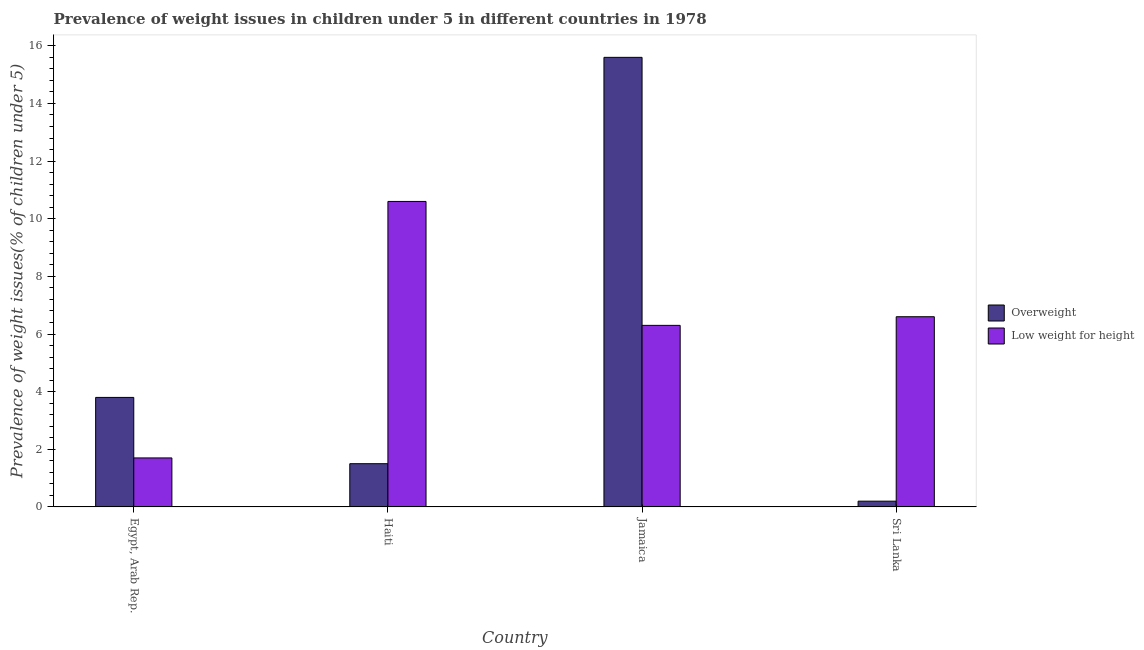How many groups of bars are there?
Provide a short and direct response. 4. Are the number of bars per tick equal to the number of legend labels?
Offer a terse response. Yes. Are the number of bars on each tick of the X-axis equal?
Offer a terse response. Yes. How many bars are there on the 4th tick from the left?
Your answer should be very brief. 2. What is the label of the 3rd group of bars from the left?
Your answer should be very brief. Jamaica. What is the percentage of underweight children in Egypt, Arab Rep.?
Provide a short and direct response. 1.7. Across all countries, what is the maximum percentage of underweight children?
Your response must be concise. 10.6. Across all countries, what is the minimum percentage of overweight children?
Your answer should be compact. 0.2. In which country was the percentage of overweight children maximum?
Provide a short and direct response. Jamaica. In which country was the percentage of overweight children minimum?
Offer a terse response. Sri Lanka. What is the total percentage of underweight children in the graph?
Your answer should be very brief. 25.2. What is the difference between the percentage of underweight children in Egypt, Arab Rep. and that in Jamaica?
Offer a terse response. -4.6. What is the difference between the percentage of overweight children in Sri Lanka and the percentage of underweight children in Egypt, Arab Rep.?
Your answer should be compact. -1.5. What is the average percentage of underweight children per country?
Keep it short and to the point. 6.3. What is the difference between the percentage of underweight children and percentage of overweight children in Jamaica?
Your answer should be compact. -9.3. In how many countries, is the percentage of underweight children greater than 15.6 %?
Provide a succinct answer. 0. What is the ratio of the percentage of underweight children in Jamaica to that in Sri Lanka?
Provide a short and direct response. 0.95. Is the percentage of overweight children in Haiti less than that in Sri Lanka?
Ensure brevity in your answer.  No. What is the difference between the highest and the second highest percentage of underweight children?
Give a very brief answer. 4. What is the difference between the highest and the lowest percentage of overweight children?
Keep it short and to the point. 15.4. What does the 2nd bar from the left in Jamaica represents?
Keep it short and to the point. Low weight for height. What does the 2nd bar from the right in Jamaica represents?
Make the answer very short. Overweight. How many bars are there?
Make the answer very short. 8. Are all the bars in the graph horizontal?
Make the answer very short. No. How many countries are there in the graph?
Provide a short and direct response. 4. What is the difference between two consecutive major ticks on the Y-axis?
Keep it short and to the point. 2. Does the graph contain grids?
Offer a very short reply. No. Where does the legend appear in the graph?
Offer a very short reply. Center right. How many legend labels are there?
Ensure brevity in your answer.  2. How are the legend labels stacked?
Ensure brevity in your answer.  Vertical. What is the title of the graph?
Your answer should be very brief. Prevalence of weight issues in children under 5 in different countries in 1978. Does "Register a property" appear as one of the legend labels in the graph?
Your answer should be compact. No. What is the label or title of the X-axis?
Your response must be concise. Country. What is the label or title of the Y-axis?
Your answer should be compact. Prevalence of weight issues(% of children under 5). What is the Prevalence of weight issues(% of children under 5) in Overweight in Egypt, Arab Rep.?
Provide a short and direct response. 3.8. What is the Prevalence of weight issues(% of children under 5) of Low weight for height in Egypt, Arab Rep.?
Provide a succinct answer. 1.7. What is the Prevalence of weight issues(% of children under 5) in Low weight for height in Haiti?
Your answer should be very brief. 10.6. What is the Prevalence of weight issues(% of children under 5) of Overweight in Jamaica?
Your answer should be compact. 15.6. What is the Prevalence of weight issues(% of children under 5) in Low weight for height in Jamaica?
Provide a short and direct response. 6.3. What is the Prevalence of weight issues(% of children under 5) of Overweight in Sri Lanka?
Your response must be concise. 0.2. What is the Prevalence of weight issues(% of children under 5) of Low weight for height in Sri Lanka?
Ensure brevity in your answer.  6.6. Across all countries, what is the maximum Prevalence of weight issues(% of children under 5) of Overweight?
Provide a succinct answer. 15.6. Across all countries, what is the maximum Prevalence of weight issues(% of children under 5) of Low weight for height?
Ensure brevity in your answer.  10.6. Across all countries, what is the minimum Prevalence of weight issues(% of children under 5) in Overweight?
Your answer should be compact. 0.2. Across all countries, what is the minimum Prevalence of weight issues(% of children under 5) in Low weight for height?
Provide a short and direct response. 1.7. What is the total Prevalence of weight issues(% of children under 5) in Overweight in the graph?
Provide a short and direct response. 21.1. What is the total Prevalence of weight issues(% of children under 5) of Low weight for height in the graph?
Give a very brief answer. 25.2. What is the difference between the Prevalence of weight issues(% of children under 5) in Overweight in Egypt, Arab Rep. and that in Haiti?
Provide a succinct answer. 2.3. What is the difference between the Prevalence of weight issues(% of children under 5) in Low weight for height in Egypt, Arab Rep. and that in Haiti?
Your answer should be compact. -8.9. What is the difference between the Prevalence of weight issues(% of children under 5) of Low weight for height in Egypt, Arab Rep. and that in Jamaica?
Give a very brief answer. -4.6. What is the difference between the Prevalence of weight issues(% of children under 5) in Overweight in Haiti and that in Jamaica?
Provide a succinct answer. -14.1. What is the difference between the Prevalence of weight issues(% of children under 5) of Low weight for height in Haiti and that in Jamaica?
Offer a very short reply. 4.3. What is the difference between the Prevalence of weight issues(% of children under 5) in Low weight for height in Haiti and that in Sri Lanka?
Offer a very short reply. 4. What is the difference between the Prevalence of weight issues(% of children under 5) of Overweight in Jamaica and that in Sri Lanka?
Your answer should be compact. 15.4. What is the difference between the Prevalence of weight issues(% of children under 5) of Overweight in Egypt, Arab Rep. and the Prevalence of weight issues(% of children under 5) of Low weight for height in Haiti?
Offer a terse response. -6.8. What is the difference between the Prevalence of weight issues(% of children under 5) of Overweight in Egypt, Arab Rep. and the Prevalence of weight issues(% of children under 5) of Low weight for height in Sri Lanka?
Ensure brevity in your answer.  -2.8. What is the average Prevalence of weight issues(% of children under 5) of Overweight per country?
Offer a terse response. 5.28. What is the average Prevalence of weight issues(% of children under 5) in Low weight for height per country?
Your answer should be very brief. 6.3. What is the difference between the Prevalence of weight issues(% of children under 5) of Overweight and Prevalence of weight issues(% of children under 5) of Low weight for height in Egypt, Arab Rep.?
Give a very brief answer. 2.1. What is the difference between the Prevalence of weight issues(% of children under 5) of Overweight and Prevalence of weight issues(% of children under 5) of Low weight for height in Sri Lanka?
Offer a terse response. -6.4. What is the ratio of the Prevalence of weight issues(% of children under 5) of Overweight in Egypt, Arab Rep. to that in Haiti?
Ensure brevity in your answer.  2.53. What is the ratio of the Prevalence of weight issues(% of children under 5) of Low weight for height in Egypt, Arab Rep. to that in Haiti?
Your answer should be very brief. 0.16. What is the ratio of the Prevalence of weight issues(% of children under 5) of Overweight in Egypt, Arab Rep. to that in Jamaica?
Offer a very short reply. 0.24. What is the ratio of the Prevalence of weight issues(% of children under 5) of Low weight for height in Egypt, Arab Rep. to that in Jamaica?
Ensure brevity in your answer.  0.27. What is the ratio of the Prevalence of weight issues(% of children under 5) of Overweight in Egypt, Arab Rep. to that in Sri Lanka?
Your answer should be very brief. 19. What is the ratio of the Prevalence of weight issues(% of children under 5) of Low weight for height in Egypt, Arab Rep. to that in Sri Lanka?
Keep it short and to the point. 0.26. What is the ratio of the Prevalence of weight issues(% of children under 5) of Overweight in Haiti to that in Jamaica?
Keep it short and to the point. 0.1. What is the ratio of the Prevalence of weight issues(% of children under 5) of Low weight for height in Haiti to that in Jamaica?
Your response must be concise. 1.68. What is the ratio of the Prevalence of weight issues(% of children under 5) of Low weight for height in Haiti to that in Sri Lanka?
Offer a terse response. 1.61. What is the ratio of the Prevalence of weight issues(% of children under 5) in Overweight in Jamaica to that in Sri Lanka?
Make the answer very short. 78. What is the ratio of the Prevalence of weight issues(% of children under 5) of Low weight for height in Jamaica to that in Sri Lanka?
Provide a succinct answer. 0.95. What is the difference between the highest and the lowest Prevalence of weight issues(% of children under 5) of Overweight?
Your answer should be compact. 15.4. What is the difference between the highest and the lowest Prevalence of weight issues(% of children under 5) in Low weight for height?
Provide a succinct answer. 8.9. 